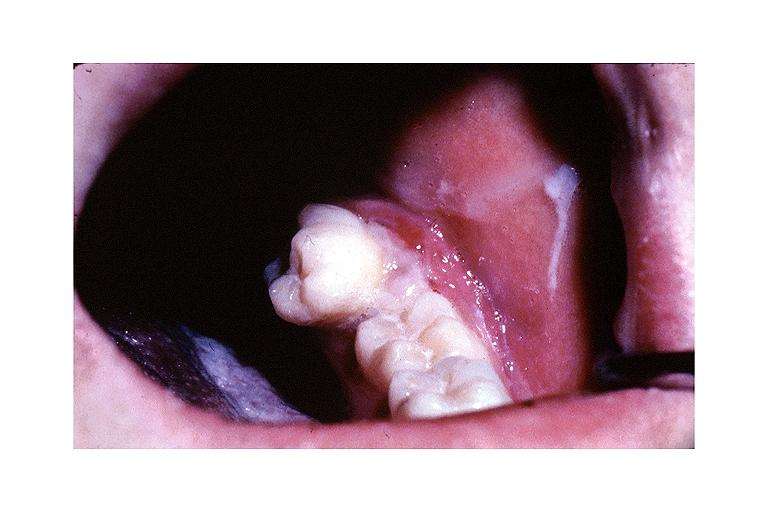where is this?
Answer the question using a single word or phrase. Oral 